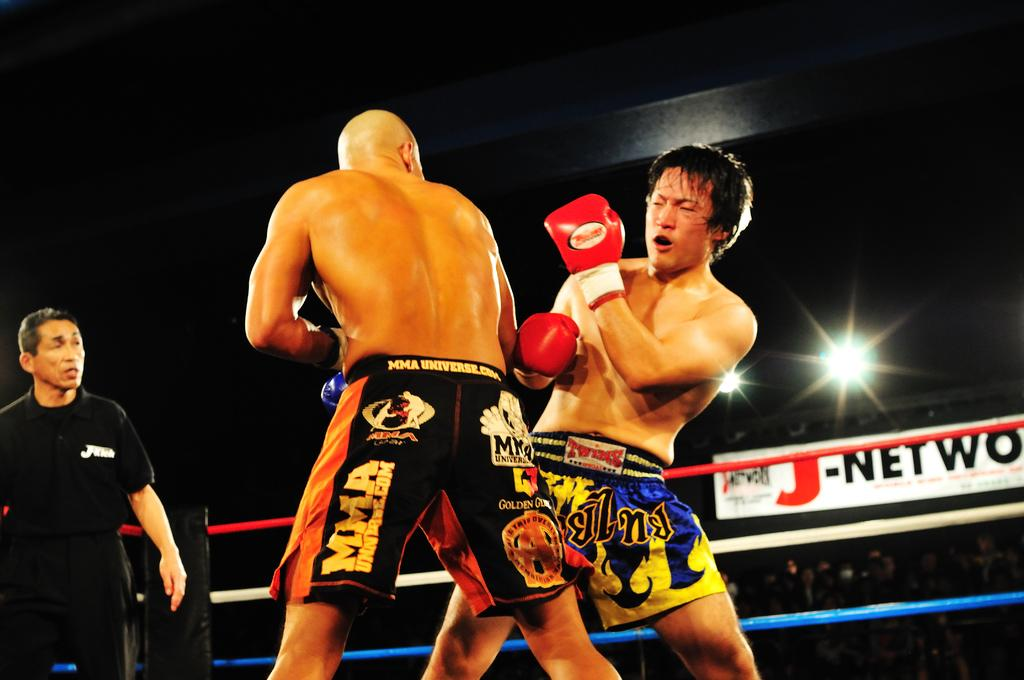<image>
Offer a succinct explanation of the picture presented. Two MMA Universe fighters close to each other while the referee observes. 